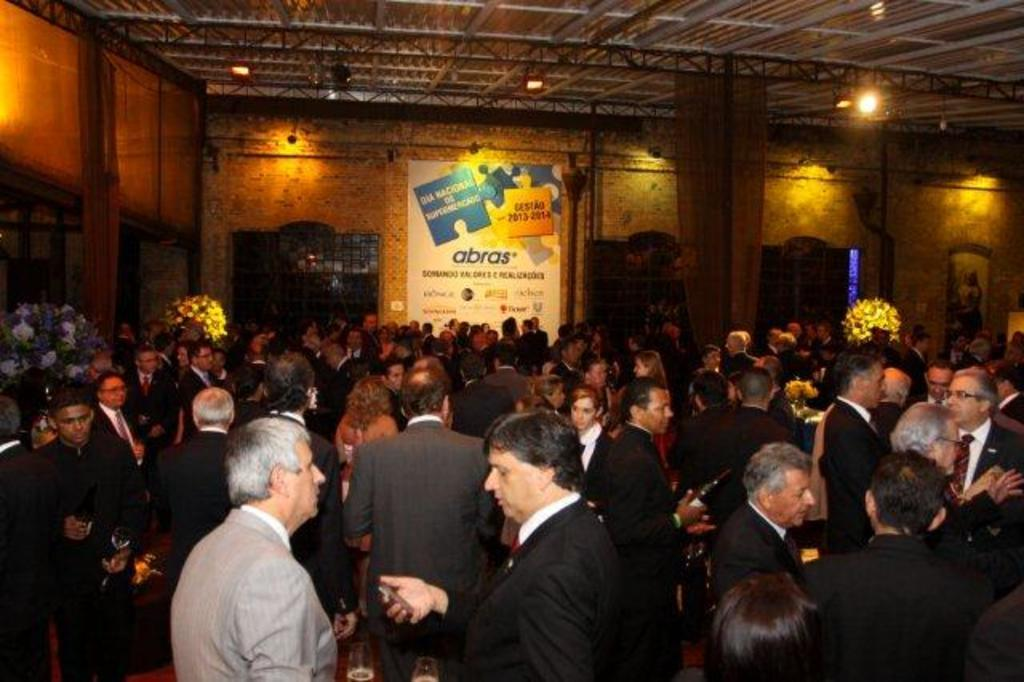How many individuals are present in the image? There are many people in the image. Where are the people located in the image? The people are standing in a closed room. What can be seen on the wall in the background of the image? There is a banner hanging on the wall in the background. What architectural feature is visible in the background of the image? There are windows in the background. What part of the room is visible at the top of the image? The ceiling is visible at the top of the image. What is the name of the person standing in the center of the image? There is no specific person mentioned in the image, so it is not possible to determine their name. 